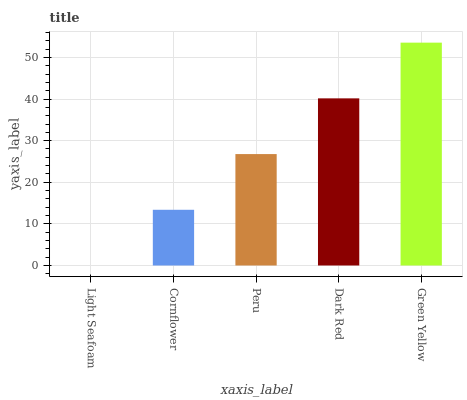Is Light Seafoam the minimum?
Answer yes or no. Yes. Is Green Yellow the maximum?
Answer yes or no. Yes. Is Cornflower the minimum?
Answer yes or no. No. Is Cornflower the maximum?
Answer yes or no. No. Is Cornflower greater than Light Seafoam?
Answer yes or no. Yes. Is Light Seafoam less than Cornflower?
Answer yes or no. Yes. Is Light Seafoam greater than Cornflower?
Answer yes or no. No. Is Cornflower less than Light Seafoam?
Answer yes or no. No. Is Peru the high median?
Answer yes or no. Yes. Is Peru the low median?
Answer yes or no. Yes. Is Dark Red the high median?
Answer yes or no. No. Is Green Yellow the low median?
Answer yes or no. No. 